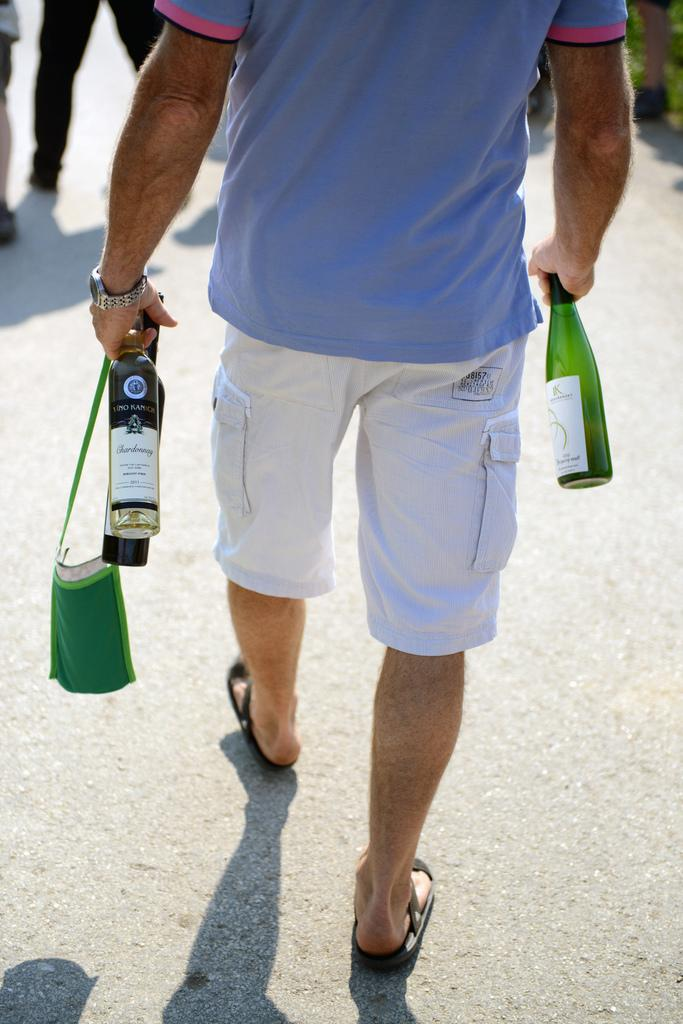What is present in the image? There is a man in the image. What is the man holding in his hand? The man is holding bottles in his hand. What is the man doing in the image? The man is walking on the road. What language is the man speaking in the image? There is no indication of the language being spoken in the image. Is the man cooking anything in the image? There is no indication that the man is cooking in the image. 